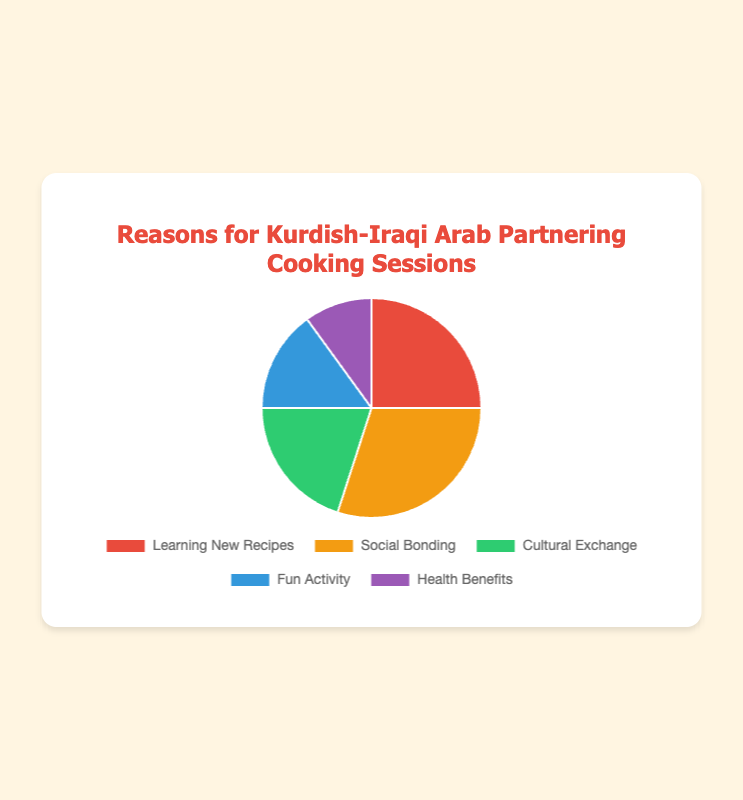What's the largest reason for partnering cooking sessions? The largest reason can be determined by looking at the segment with the largest percentage in the pie chart. The segment for Social Bonding is the largest with 30%.
Answer: Social Bonding Which reason has the smallest percentage in the pie chart? The smallest percentage is determined by identifying the smallest segment. The segment for Health Benefits is the smallest with 10%.
Answer: Health Benefits Is learning new recipes more popular than a fun activity? Compare the percentages of Learning New Recipes and Fun Activity. Learning New Recipes has 25%, while Fun Activity has 15%, so Learning New Recipes is more popular.
Answer: Yes What are the combined percentages of Social Bonding and Cultural Exchange? Add the percentages for Social Bonding and Cultural Exchange. Social Bonding is 30% and Cultural Exchange is 20%, so the combined percentage is 30% + 20% = 50%.
Answer: 50% What is the combined percentage of reasons relating to direct personal benefits (Learning New Recipes and Health Benefits)? Add the percentages for Learning New Recipes and Health Benefits. Learning New Recipes is 25% and Health Benefits is 10%, so the combined percentage is 25% + 10% = 35%.
Answer: 35% Which segment is larger, Cultural Exchange or Fun Activity? Compare the percentages of Cultural Exchange and Fun Activity. Cultural Exchange has 20% and Fun Activity has 15%, so Cultural Exchange is larger.
Answer: Cultural Exchange How much larger is Social Bonding compared to Health Benefits? Subtract the percentage of Health Benefits from Social Bonding. Social Bonding is 30% and Health Benefits is 10%, so the difference is 30% - 10% = 20%.
Answer: 20% What is the average percentage of the top three reasons? Find the average percentage of Social Bonding (30%), Learning New Recipes (25%), and Cultural Exchange (20%). The sum is 30% + 25% + 20% = 75%, and the average is 75% / 3 = 25%.
Answer: 25% Which reasons have percentages between 10% and 25%? Check the percentages that fall between 10% and 25%. Learning New Recipes (25%), Cultural Exchange (20%), and Fun Activity (15%) fall within this range.
Answer: Learning New Recipes, Cultural Exchange, Fun Activity What color represents Fun Activity in the pie chart? Identify the segment for Fun Activity and note its color. The Fun Activity segment is represented by blue.
Answer: Blue 